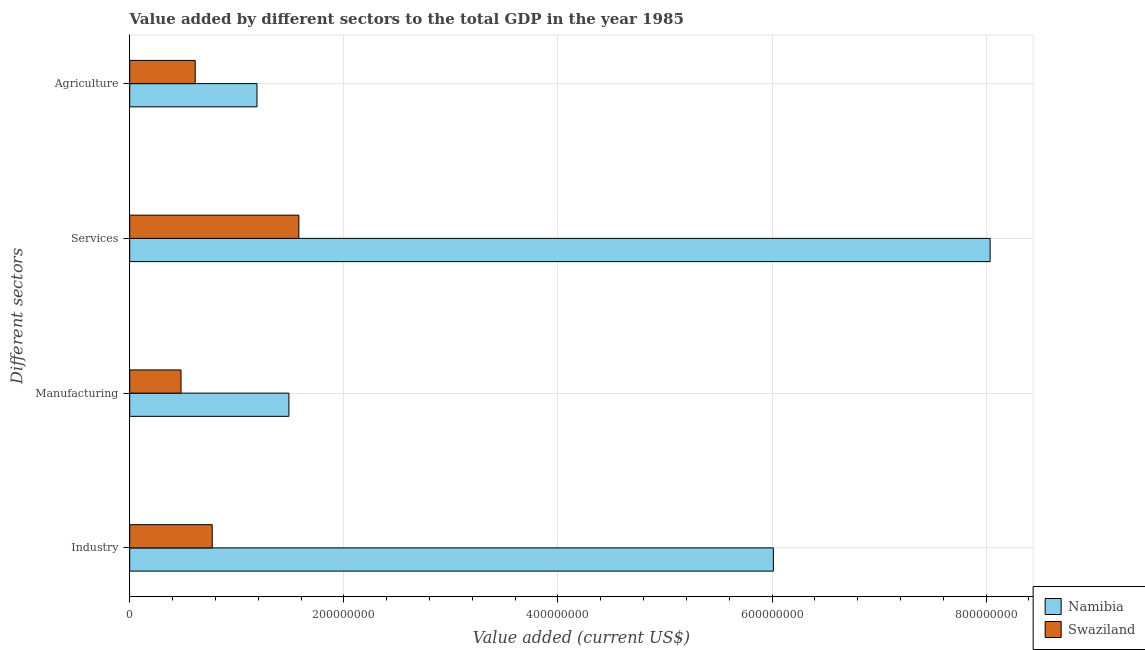Are the number of bars per tick equal to the number of legend labels?
Your answer should be compact. Yes. Are the number of bars on each tick of the Y-axis equal?
Make the answer very short. Yes. How many bars are there on the 2nd tick from the top?
Your answer should be very brief. 2. What is the label of the 1st group of bars from the top?
Make the answer very short. Agriculture. What is the value added by industrial sector in Swaziland?
Your response must be concise. 7.71e+07. Across all countries, what is the maximum value added by manufacturing sector?
Give a very brief answer. 1.49e+08. Across all countries, what is the minimum value added by agricultural sector?
Your answer should be compact. 6.12e+07. In which country was the value added by industrial sector maximum?
Your response must be concise. Namibia. In which country was the value added by manufacturing sector minimum?
Ensure brevity in your answer.  Swaziland. What is the total value added by industrial sector in the graph?
Offer a terse response. 6.78e+08. What is the difference between the value added by industrial sector in Swaziland and that in Namibia?
Make the answer very short. -5.24e+08. What is the difference between the value added by industrial sector in Swaziland and the value added by agricultural sector in Namibia?
Offer a terse response. -4.18e+07. What is the average value added by agricultural sector per country?
Keep it short and to the point. 9.00e+07. What is the difference between the value added by services sector and value added by industrial sector in Namibia?
Provide a short and direct response. 2.02e+08. In how many countries, is the value added by manufacturing sector greater than 280000000 US$?
Provide a succinct answer. 0. What is the ratio of the value added by manufacturing sector in Namibia to that in Swaziland?
Offer a very short reply. 3.1. Is the difference between the value added by services sector in Swaziland and Namibia greater than the difference between the value added by agricultural sector in Swaziland and Namibia?
Your answer should be compact. No. What is the difference between the highest and the second highest value added by industrial sector?
Keep it short and to the point. 5.24e+08. What is the difference between the highest and the lowest value added by industrial sector?
Provide a short and direct response. 5.24e+08. Is the sum of the value added by services sector in Namibia and Swaziland greater than the maximum value added by industrial sector across all countries?
Provide a succinct answer. Yes. Is it the case that in every country, the sum of the value added by industrial sector and value added by services sector is greater than the sum of value added by agricultural sector and value added by manufacturing sector?
Your answer should be compact. Yes. What does the 2nd bar from the top in Industry represents?
Your response must be concise. Namibia. What does the 2nd bar from the bottom in Industry represents?
Your answer should be very brief. Swaziland. How many bars are there?
Your answer should be very brief. 8. Are all the bars in the graph horizontal?
Offer a very short reply. Yes. How many countries are there in the graph?
Give a very brief answer. 2. What is the difference between two consecutive major ticks on the X-axis?
Make the answer very short. 2.00e+08. Does the graph contain any zero values?
Your response must be concise. No. How many legend labels are there?
Offer a very short reply. 2. How are the legend labels stacked?
Give a very brief answer. Vertical. What is the title of the graph?
Make the answer very short. Value added by different sectors to the total GDP in the year 1985. What is the label or title of the X-axis?
Give a very brief answer. Value added (current US$). What is the label or title of the Y-axis?
Offer a very short reply. Different sectors. What is the Value added (current US$) in Namibia in Industry?
Give a very brief answer. 6.01e+08. What is the Value added (current US$) in Swaziland in Industry?
Keep it short and to the point. 7.71e+07. What is the Value added (current US$) in Namibia in Manufacturing?
Your answer should be compact. 1.49e+08. What is the Value added (current US$) in Swaziland in Manufacturing?
Provide a succinct answer. 4.79e+07. What is the Value added (current US$) in Namibia in Services?
Your answer should be very brief. 8.04e+08. What is the Value added (current US$) in Swaziland in Services?
Offer a terse response. 1.58e+08. What is the Value added (current US$) of Namibia in Agriculture?
Keep it short and to the point. 1.19e+08. What is the Value added (current US$) of Swaziland in Agriculture?
Give a very brief answer. 6.12e+07. Across all Different sectors, what is the maximum Value added (current US$) of Namibia?
Make the answer very short. 8.04e+08. Across all Different sectors, what is the maximum Value added (current US$) of Swaziland?
Ensure brevity in your answer.  1.58e+08. Across all Different sectors, what is the minimum Value added (current US$) of Namibia?
Your answer should be very brief. 1.19e+08. Across all Different sectors, what is the minimum Value added (current US$) in Swaziland?
Your answer should be compact. 4.79e+07. What is the total Value added (current US$) of Namibia in the graph?
Give a very brief answer. 1.67e+09. What is the total Value added (current US$) in Swaziland in the graph?
Your answer should be very brief. 3.44e+08. What is the difference between the Value added (current US$) of Namibia in Industry and that in Manufacturing?
Make the answer very short. 4.53e+08. What is the difference between the Value added (current US$) in Swaziland in Industry and that in Manufacturing?
Provide a short and direct response. 2.92e+07. What is the difference between the Value added (current US$) in Namibia in Industry and that in Services?
Keep it short and to the point. -2.02e+08. What is the difference between the Value added (current US$) in Swaziland in Industry and that in Services?
Your answer should be very brief. -8.09e+07. What is the difference between the Value added (current US$) in Namibia in Industry and that in Agriculture?
Give a very brief answer. 4.82e+08. What is the difference between the Value added (current US$) in Swaziland in Industry and that in Agriculture?
Your answer should be compact. 1.59e+07. What is the difference between the Value added (current US$) of Namibia in Manufacturing and that in Services?
Make the answer very short. -6.55e+08. What is the difference between the Value added (current US$) in Swaziland in Manufacturing and that in Services?
Your answer should be very brief. -1.10e+08. What is the difference between the Value added (current US$) in Namibia in Manufacturing and that in Agriculture?
Provide a short and direct response. 2.98e+07. What is the difference between the Value added (current US$) of Swaziland in Manufacturing and that in Agriculture?
Your answer should be very brief. -1.33e+07. What is the difference between the Value added (current US$) in Namibia in Services and that in Agriculture?
Make the answer very short. 6.85e+08. What is the difference between the Value added (current US$) of Swaziland in Services and that in Agriculture?
Your answer should be compact. 9.68e+07. What is the difference between the Value added (current US$) of Namibia in Industry and the Value added (current US$) of Swaziland in Manufacturing?
Offer a terse response. 5.53e+08. What is the difference between the Value added (current US$) of Namibia in Industry and the Value added (current US$) of Swaziland in Services?
Ensure brevity in your answer.  4.43e+08. What is the difference between the Value added (current US$) in Namibia in Industry and the Value added (current US$) in Swaziland in Agriculture?
Make the answer very short. 5.40e+08. What is the difference between the Value added (current US$) of Namibia in Manufacturing and the Value added (current US$) of Swaziland in Services?
Provide a short and direct response. -9.30e+06. What is the difference between the Value added (current US$) of Namibia in Manufacturing and the Value added (current US$) of Swaziland in Agriculture?
Offer a terse response. 8.75e+07. What is the difference between the Value added (current US$) in Namibia in Services and the Value added (current US$) in Swaziland in Agriculture?
Give a very brief answer. 7.43e+08. What is the average Value added (current US$) of Namibia per Different sectors?
Ensure brevity in your answer.  4.18e+08. What is the average Value added (current US$) of Swaziland per Different sectors?
Your answer should be very brief. 8.60e+07. What is the difference between the Value added (current US$) in Namibia and Value added (current US$) in Swaziland in Industry?
Your answer should be compact. 5.24e+08. What is the difference between the Value added (current US$) in Namibia and Value added (current US$) in Swaziland in Manufacturing?
Offer a terse response. 1.01e+08. What is the difference between the Value added (current US$) in Namibia and Value added (current US$) in Swaziland in Services?
Offer a terse response. 6.46e+08. What is the difference between the Value added (current US$) of Namibia and Value added (current US$) of Swaziland in Agriculture?
Ensure brevity in your answer.  5.77e+07. What is the ratio of the Value added (current US$) in Namibia in Industry to that in Manufacturing?
Offer a terse response. 4.04. What is the ratio of the Value added (current US$) of Swaziland in Industry to that in Manufacturing?
Make the answer very short. 1.61. What is the ratio of the Value added (current US$) of Namibia in Industry to that in Services?
Give a very brief answer. 0.75. What is the ratio of the Value added (current US$) of Swaziland in Industry to that in Services?
Your answer should be very brief. 0.49. What is the ratio of the Value added (current US$) in Namibia in Industry to that in Agriculture?
Give a very brief answer. 5.06. What is the ratio of the Value added (current US$) of Swaziland in Industry to that in Agriculture?
Your answer should be compact. 1.26. What is the ratio of the Value added (current US$) of Namibia in Manufacturing to that in Services?
Your answer should be compact. 0.18. What is the ratio of the Value added (current US$) in Swaziland in Manufacturing to that in Services?
Your answer should be very brief. 0.3. What is the ratio of the Value added (current US$) in Namibia in Manufacturing to that in Agriculture?
Ensure brevity in your answer.  1.25. What is the ratio of the Value added (current US$) of Swaziland in Manufacturing to that in Agriculture?
Your answer should be very brief. 0.78. What is the ratio of the Value added (current US$) of Namibia in Services to that in Agriculture?
Your answer should be compact. 6.76. What is the ratio of the Value added (current US$) in Swaziland in Services to that in Agriculture?
Offer a terse response. 2.58. What is the difference between the highest and the second highest Value added (current US$) in Namibia?
Provide a succinct answer. 2.02e+08. What is the difference between the highest and the second highest Value added (current US$) in Swaziland?
Offer a very short reply. 8.09e+07. What is the difference between the highest and the lowest Value added (current US$) in Namibia?
Provide a succinct answer. 6.85e+08. What is the difference between the highest and the lowest Value added (current US$) in Swaziland?
Provide a short and direct response. 1.10e+08. 